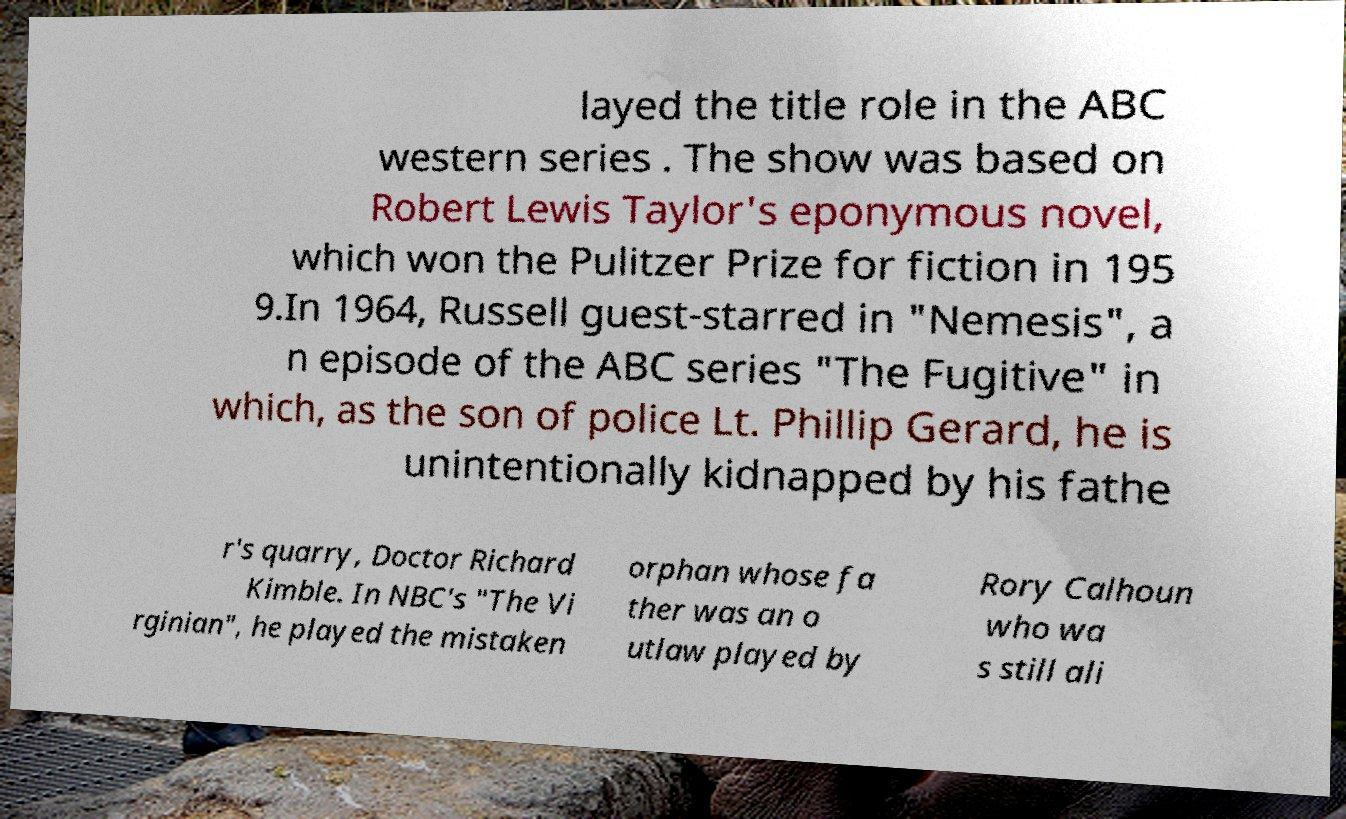Could you extract and type out the text from this image? layed the title role in the ABC western series . The show was based on Robert Lewis Taylor's eponymous novel, which won the Pulitzer Prize for fiction in 195 9.In 1964, Russell guest-starred in "Nemesis", a n episode of the ABC series "The Fugitive" in which, as the son of police Lt. Phillip Gerard, he is unintentionally kidnapped by his fathe r's quarry, Doctor Richard Kimble. In NBC's "The Vi rginian", he played the mistaken orphan whose fa ther was an o utlaw played by Rory Calhoun who wa s still ali 